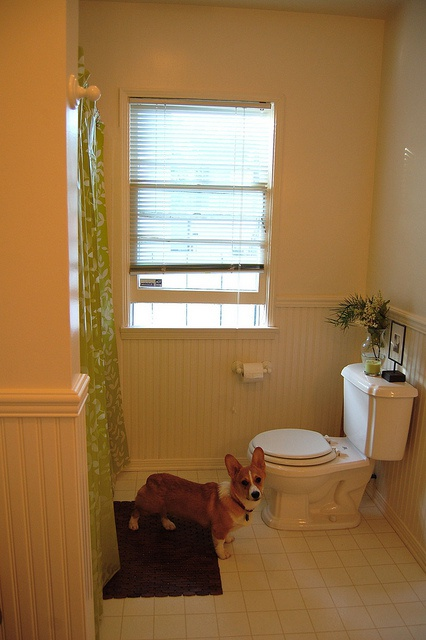Describe the objects in this image and their specific colors. I can see toilet in brown, olive, darkgray, gray, and maroon tones, dog in brown, maroon, and black tones, potted plant in brown, olive, and black tones, and vase in brown, olive, gray, and black tones in this image. 